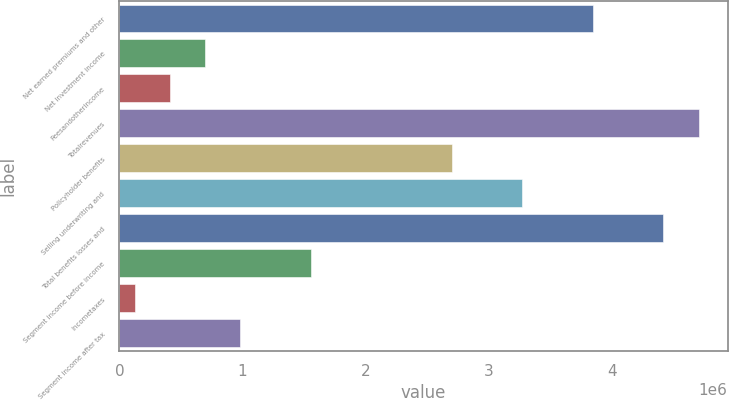Convert chart to OTSL. <chart><loc_0><loc_0><loc_500><loc_500><bar_chart><fcel>Net earned premiums and other<fcel>Net investment income<fcel>Feesandotherincome<fcel>Totalrevenues<fcel>Policyholder benefits<fcel>Selling underwriting and<fcel>Total benefits losses and<fcel>Segment income before income<fcel>Incometaxes<fcel>Segment income after tax<nl><fcel>3.84354e+06<fcel>695457<fcel>409268<fcel>4.70211e+06<fcel>2.69878e+06<fcel>3.27116e+06<fcel>4.41592e+06<fcel>1.55403e+06<fcel>123078<fcel>981646<nl></chart> 